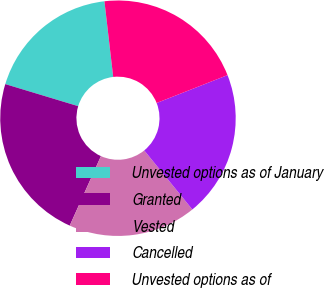Convert chart. <chart><loc_0><loc_0><loc_500><loc_500><pie_chart><fcel>Unvested options as of January<fcel>Granted<fcel>Vested<fcel>Cancelled<fcel>Unvested options as of<nl><fcel>18.49%<fcel>22.96%<fcel>17.6%<fcel>20.08%<fcel>20.87%<nl></chart> 